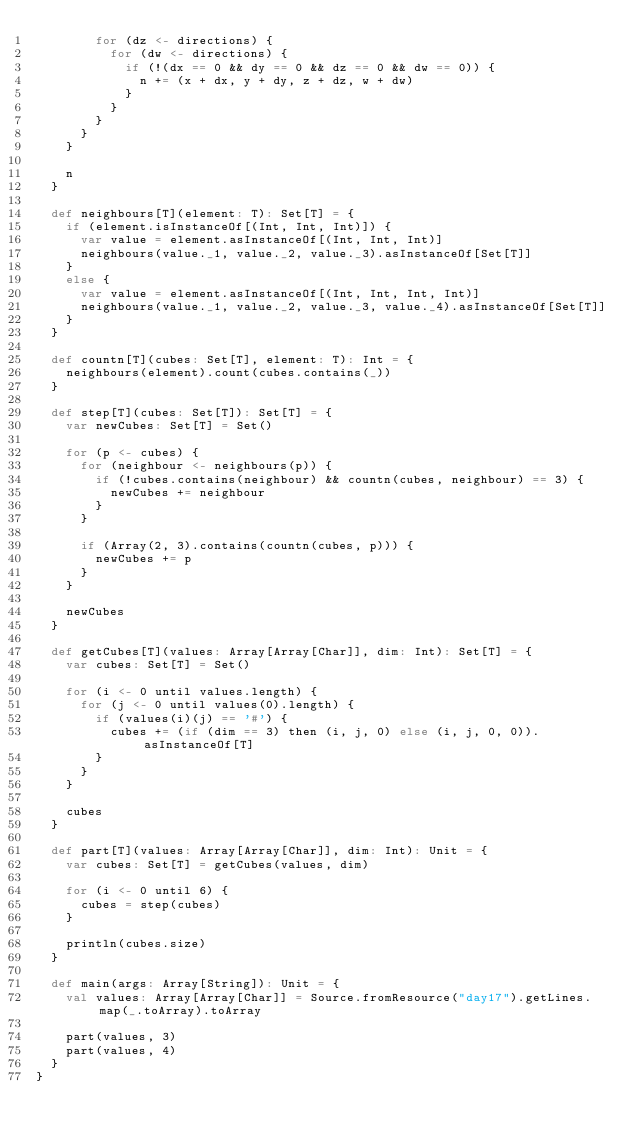<code> <loc_0><loc_0><loc_500><loc_500><_Scala_>        for (dz <- directions) {
          for (dw <- directions) {
            if (!(dx == 0 && dy == 0 && dz == 0 && dw == 0)) {
              n += (x + dx, y + dy, z + dz, w + dw)
            }
          }
        }
      }
    }

    n
  } 
  
  def neighbours[T](element: T): Set[T] = {
    if (element.isInstanceOf[(Int, Int, Int)]) {
      var value = element.asInstanceOf[(Int, Int, Int)]
      neighbours(value._1, value._2, value._3).asInstanceOf[Set[T]]
    }
    else {
      var value = element.asInstanceOf[(Int, Int, Int, Int)]
      neighbours(value._1, value._2, value._3, value._4).asInstanceOf[Set[T]]
    }
  }
  
  def countn[T](cubes: Set[T], element: T): Int = {
    neighbours(element).count(cubes.contains(_))
  }
  
  def step[T](cubes: Set[T]): Set[T] = {
    var newCubes: Set[T] = Set()
    
    for (p <- cubes) {
      for (neighbour <- neighbours(p)) {
        if (!cubes.contains(neighbour) && countn(cubes, neighbour) == 3) {
          newCubes += neighbour
        }
      }

      if (Array(2, 3).contains(countn(cubes, p))) {
        newCubes += p
      }
    }

    newCubes
  }
  
  def getCubes[T](values: Array[Array[Char]], dim: Int): Set[T] = {
    var cubes: Set[T] = Set()

    for (i <- 0 until values.length) {
      for (j <- 0 until values(0).length) {
        if (values(i)(j) == '#') {
          cubes += (if (dim == 3) then (i, j, 0) else (i, j, 0, 0)).asInstanceOf[T]
        }
      }
    }
    
    cubes
  }
  
  def part[T](values: Array[Array[Char]], dim: Int): Unit = {
    var cubes: Set[T] = getCubes(values, dim)
    
    for (i <- 0 until 6) {
      cubes = step(cubes)
    }
    
    println(cubes.size)
  }
  
  def main(args: Array[String]): Unit = {
    val values: Array[Array[Char]] = Source.fromResource("day17").getLines.map(_.toArray).toArray
    
    part(values, 3)
    part(values, 4)
  }
}</code> 